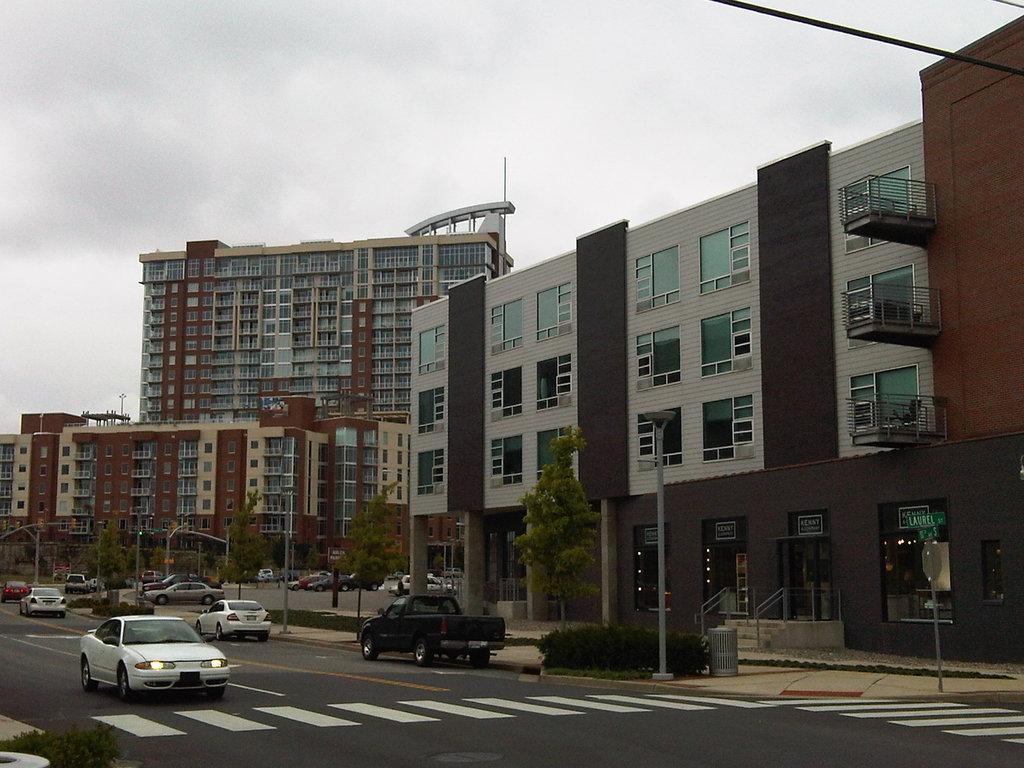Could you give a brief overview of what you see in this image? In this image in the center there are some buildings, trees, poles and there are some vehicles on the road and also i can see some lights. At the top there is sky and some wires. 